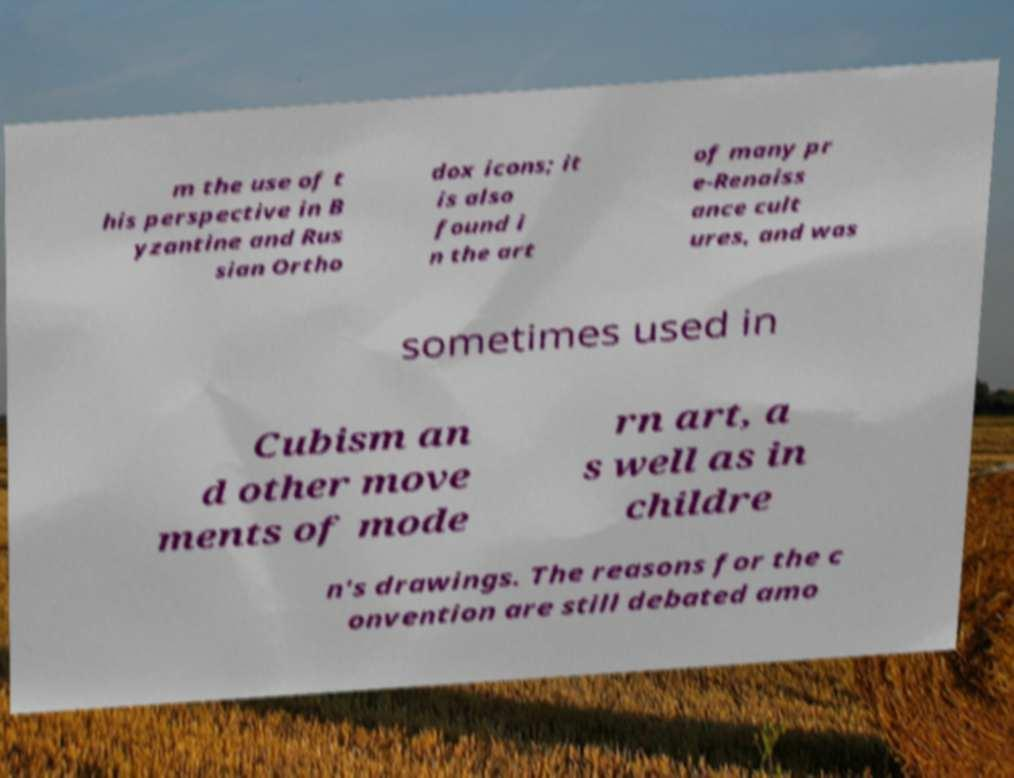Can you accurately transcribe the text from the provided image for me? m the use of t his perspective in B yzantine and Rus sian Ortho dox icons; it is also found i n the art of many pr e-Renaiss ance cult ures, and was sometimes used in Cubism an d other move ments of mode rn art, a s well as in childre n's drawings. The reasons for the c onvention are still debated amo 